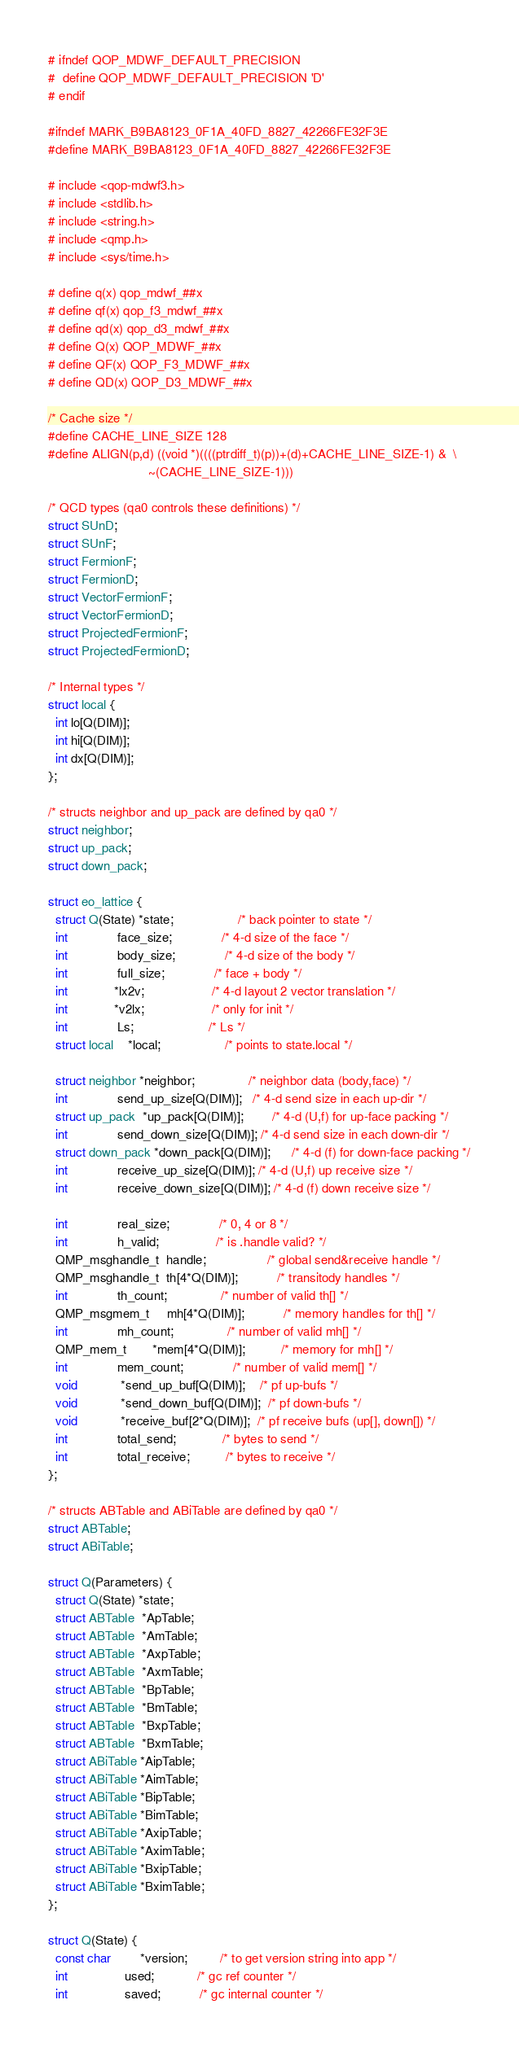<code> <loc_0><loc_0><loc_500><loc_500><_C_># ifndef QOP_MDWF_DEFAULT_PRECISION
#  define QOP_MDWF_DEFAULT_PRECISION 'D'
# endif

#ifndef MARK_B9BA8123_0F1A_40FD_8827_42266FE32F3E
#define MARK_B9BA8123_0F1A_40FD_8827_42266FE32F3E

# include <qop-mdwf3.h>
# include <stdlib.h>
# include <string.h>
# include <qmp.h>
# include <sys/time.h>

# define q(x) qop_mdwf_##x
# define qf(x) qop_f3_mdwf_##x
# define qd(x) qop_d3_mdwf_##x
# define Q(x) QOP_MDWF_##x
# define QF(x) QOP_F3_MDWF_##x
# define QD(x) QOP_D3_MDWF_##x

/* Cache size */
#define CACHE_LINE_SIZE 128
#define ALIGN(p,d) ((void *)((((ptrdiff_t)(p))+(d)+CACHE_LINE_SIZE-1) &  \
                            ~(CACHE_LINE_SIZE-1)))

/* QCD types (qa0 controls these definitions) */
struct SUnD;
struct SUnF;
struct FermionF;
struct FermionD;
struct VectorFermionF;
struct VectorFermionD;
struct ProjectedFermionF;
struct ProjectedFermionD;

/* Internal types */
struct local {
  int lo[Q(DIM)];
  int hi[Q(DIM)];
  int dx[Q(DIM)];
};

/* structs neighbor and up_pack are defined by qa0 */
struct neighbor;
struct up_pack;
struct down_pack;

struct eo_lattice {
  struct Q(State) *state;                  /* back pointer to state */
  int              face_size;              /* 4-d size of the face */
  int              body_size;              /* 4-d size of the body */
  int              full_size;              /* face + body */
  int             *lx2v;                   /* 4-d layout 2 vector translation */
  int             *v2lx;                   /* only for init */
  int              Ls;                     /* Ls */
  struct local    *local;                  /* points to state.local */

  struct neighbor *neighbor;               /* neighbor data (body,face) */
  int              send_up_size[Q(DIM)];   /* 4-d send size in each up-dir */
  struct up_pack  *up_pack[Q(DIM)];        /* 4-d (U,f) for up-face packing */
  int              send_down_size[Q(DIM)]; /* 4-d send size in each down-dir */
  struct down_pack *down_pack[Q(DIM)];      /* 4-d (f) for down-face packing */
  int              receive_up_size[Q(DIM)]; /* 4-d (U,f) up receive size */
  int              receive_down_size[Q(DIM)]; /* 4-d (f) down receive size */

  int              real_size;              /* 0, 4 or 8 */ 
  int              h_valid;                /* is .handle valid? */
  QMP_msghandle_t  handle;                 /* global send&receive handle */
  QMP_msghandle_t  th[4*Q(DIM)];           /* transitody handles */
  int              th_count;               /* number of valid th[] */
  QMP_msgmem_t     mh[4*Q(DIM)];           /* memory handles for th[] */
  int              mh_count;               /* number of valid mh[] */
  QMP_mem_t       *mem[4*Q(DIM)];          /* memory for mh[] */
  int              mem_count;              /* number of valid mem[] */
  void            *send_up_buf[Q(DIM)];    /* pf up-bufs */
  void            *send_down_buf[Q(DIM)];  /* pf down-bufs */
  void            *receive_buf[2*Q(DIM)];  /* pf receive bufs (up[], down[]) */
  int              total_send;             /* bytes to send */
  int              total_receive;          /* bytes to receive */
};

/* structs ABTable and ABiTable are defined by qa0 */
struct ABTable;
struct ABiTable;

struct Q(Parameters) {
  struct Q(State) *state;
  struct ABTable  *ApTable;
  struct ABTable  *AmTable;
  struct ABTable  *AxpTable;
  struct ABTable  *AxmTable;
  struct ABTable  *BpTable;
  struct ABTable  *BmTable;
  struct ABTable  *BxpTable;
  struct ABTable  *BxmTable;
  struct ABiTable *AipTable;
  struct ABiTable *AimTable;
  struct ABiTable *BipTable;
  struct ABiTable *BimTable;
  struct ABiTable *AxipTable;
  struct ABiTable *AximTable;
  struct ABiTable *BxipTable;
  struct ABiTable *BximTable;
};

struct Q(State) {
  const char        *version;         /* to get version string into app */
  int                used;            /* gc ref counter */
  int                saved;           /* gc internal counter */</code> 